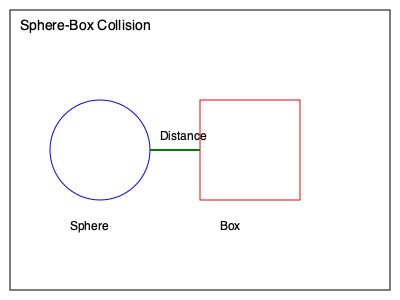In a 3D game engine, you need to implement collision detection between a sphere and a box. Which method would be most efficient in terms of computational complexity and why: Sphere-AABB (Axis-Aligned Bounding Box) test, GJK (Gilbert-Johnson-Keerthi) algorithm, or SAT (Separating Axis Theorem)? To determine the most efficient method for sphere-box collision detection, let's analyze each approach:

1. Sphere-AABB test:
   - Complexity: $O(1)$
   - Steps:
     a) Find the closest point on the AABB to the sphere's center
     b) Calculate the distance between this point and the sphere's center
     c) Compare the distance with the sphere's radius

2. GJK (Gilbert-Johnson-Keerthi) algorithm:
   - Complexity: $O(n)$, where n is the number of iterations (usually small)
   - Steps:
     a) Iteratively construct a simplex in Minkowski difference space
     b) Check if the simplex contains the origin
     c) Refine the simplex until collision is determined or ruled out

3. SAT (Separating Axis Theorem):
   - Complexity: $O(m)$, where m is the number of axes to test
   - Steps:
     a) Generate potential separating axes (face normals and edge cross products)
     b) Project shapes onto each axis
     c) Check for overlap on all axes

For sphere-box collision:
- Sphere-AABB test is specifically designed for this scenario and has constant time complexity.
- GJK is more general but requires multiple iterations.
- SAT is overkill for this simple case and requires testing multiple axes.

Therefore, the Sphere-AABB test is the most efficient method for this specific collision detection scenario due to its constant time complexity and direct approach tailored to sphere-box interactions.
Answer: Sphere-AABB test (constant time complexity, specifically designed for sphere-box collisions) 